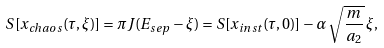<formula> <loc_0><loc_0><loc_500><loc_500>S [ x _ { c h a o s } ( \tau , \xi ) ] = \pi J ( E _ { s e p } - \xi ) = S [ x _ { i n s t } ( \tau , 0 ) ] - \alpha \, \sqrt { \frac { m } { a _ { 2 } } } \, \xi ,</formula> 